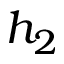Convert formula to latex. <formula><loc_0><loc_0><loc_500><loc_500>h _ { 2 }</formula> 